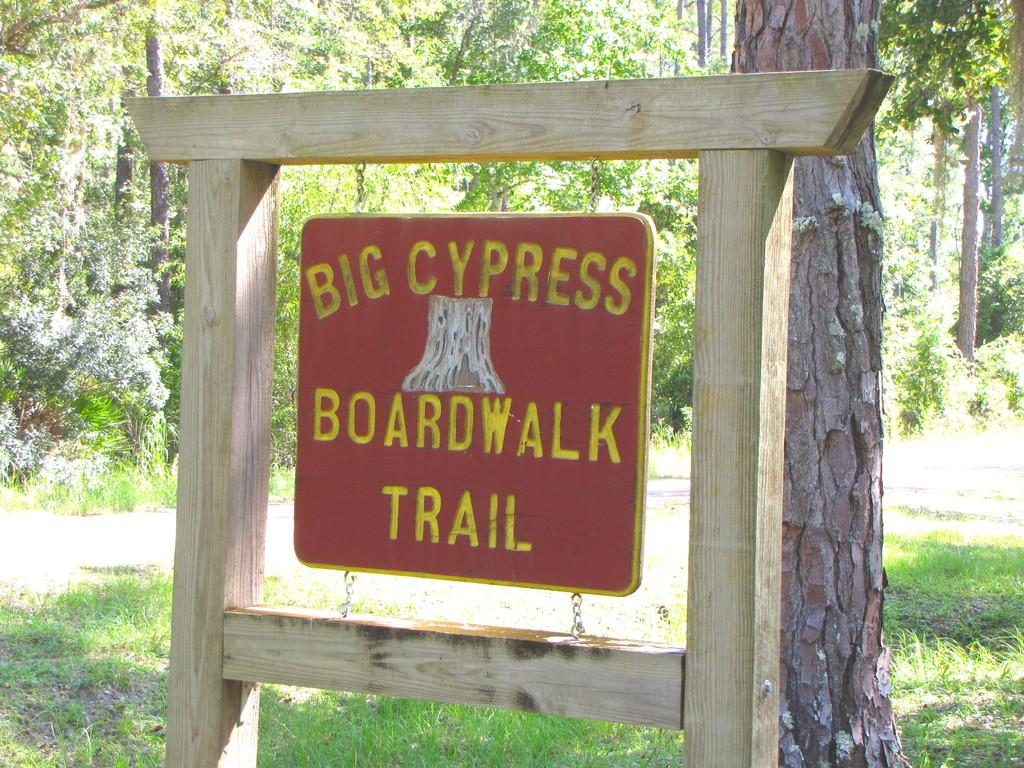What is displayed on the board in the image? There is a board with a street name in the image. How is the board positioned in the image? The board is hanging on poles. What type of natural elements can be seen in the image? There are trees visible in the image. What type of man-made structure is present in the image? There is a road in the image. How many brothers are standing near the tree in the image? There are no brothers or tree present in the image. 